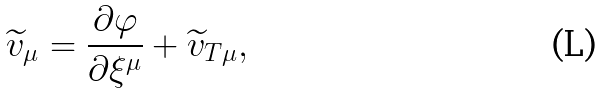<formula> <loc_0><loc_0><loc_500><loc_500>\widetilde { v } _ { \mu } = \frac { \partial \varphi } { \partial \xi ^ { \mu } } + \widetilde { v } _ { T \mu } ,</formula> 